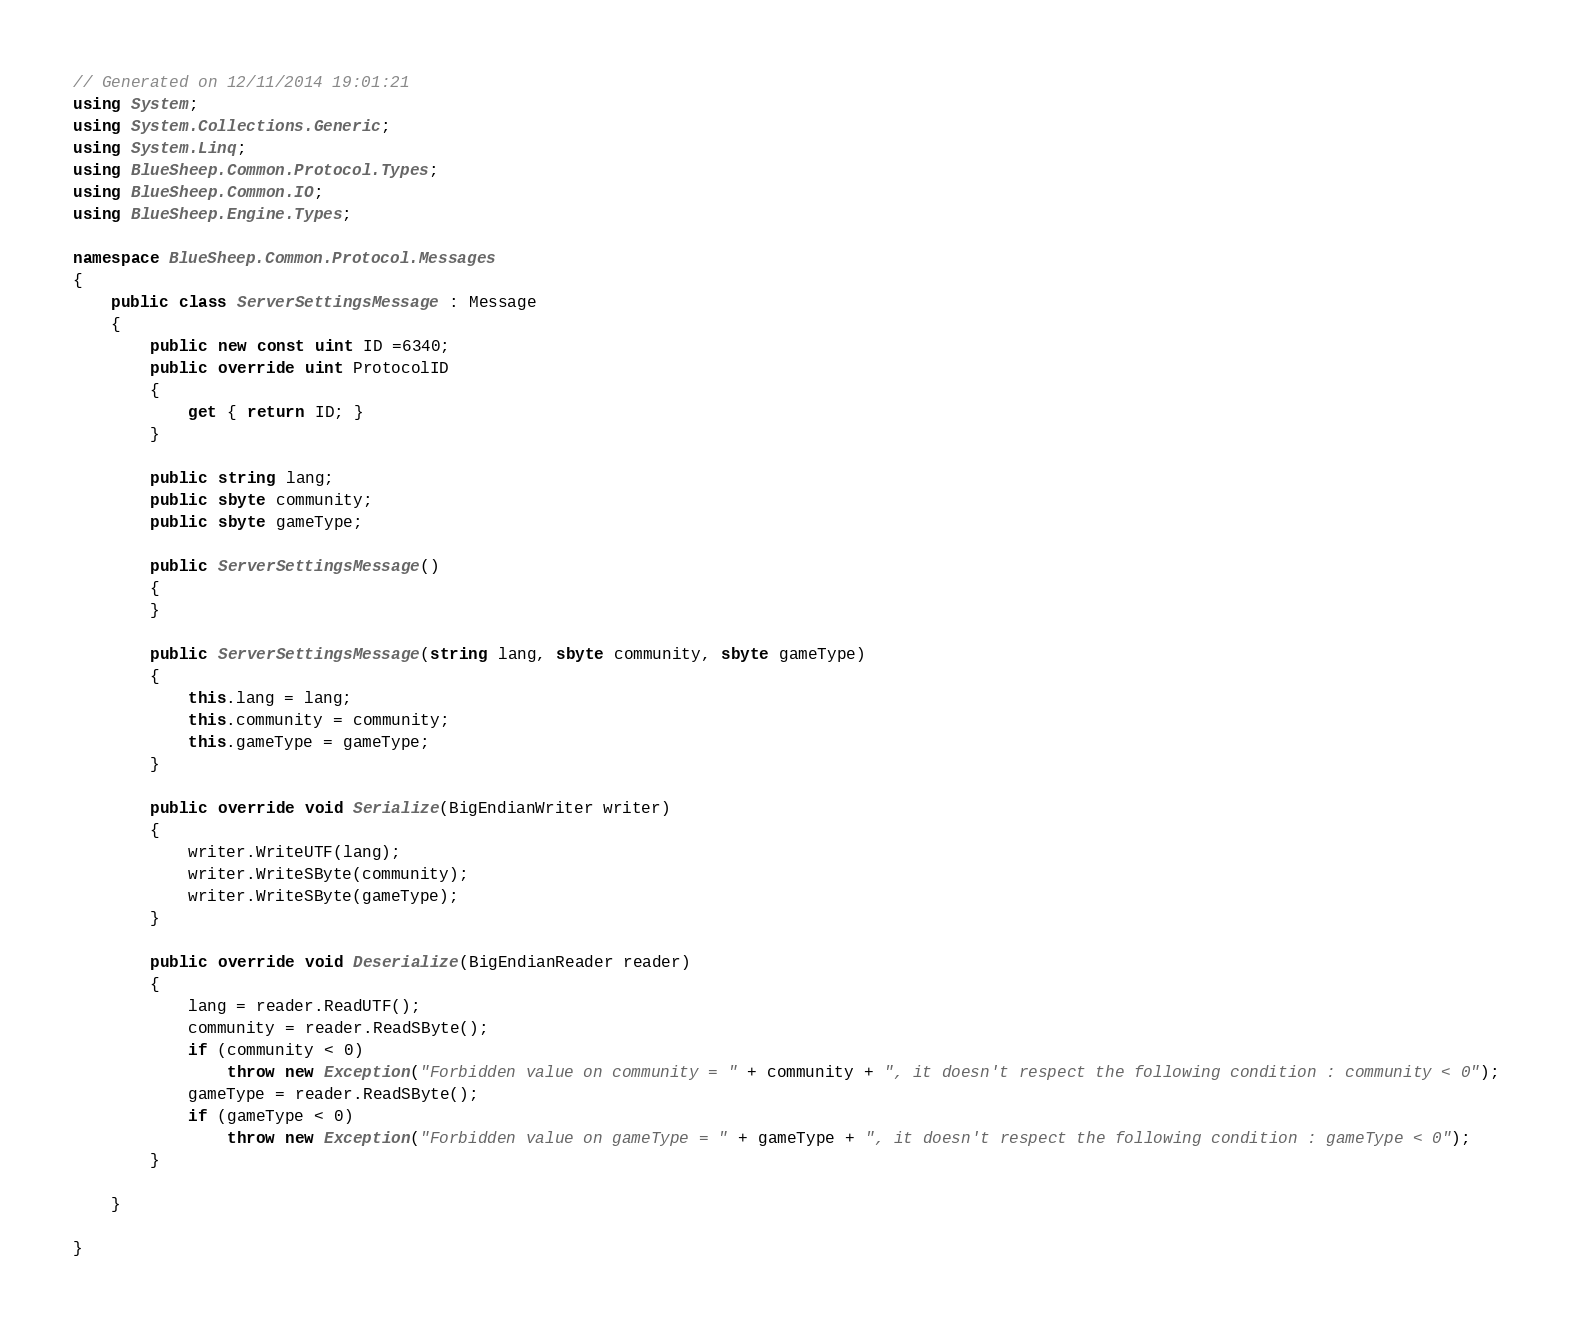Convert code to text. <code><loc_0><loc_0><loc_500><loc_500><_C#_>









// Generated on 12/11/2014 19:01:21
using System;
using System.Collections.Generic;
using System.Linq;
using BlueSheep.Common.Protocol.Types;
using BlueSheep.Common.IO;
using BlueSheep.Engine.Types;

namespace BlueSheep.Common.Protocol.Messages
{
    public class ServerSettingsMessage : Message
    {
        public new const uint ID =6340;
        public override uint ProtocolID
        {
            get { return ID; }
        }
        
        public string lang;
        public sbyte community;
        public sbyte gameType;
        
        public ServerSettingsMessage()
        {
        }
        
        public ServerSettingsMessage(string lang, sbyte community, sbyte gameType)
        {
            this.lang = lang;
            this.community = community;
            this.gameType = gameType;
        }
        
        public override void Serialize(BigEndianWriter writer)
        {
            writer.WriteUTF(lang);
            writer.WriteSByte(community);
            writer.WriteSByte(gameType);
        }
        
        public override void Deserialize(BigEndianReader reader)
        {
            lang = reader.ReadUTF();
            community = reader.ReadSByte();
            if (community < 0)
                throw new Exception("Forbidden value on community = " + community + ", it doesn't respect the following condition : community < 0");
            gameType = reader.ReadSByte();
            if (gameType < 0)
                throw new Exception("Forbidden value on gameType = " + gameType + ", it doesn't respect the following condition : gameType < 0");
        }
        
    }
    
}</code> 